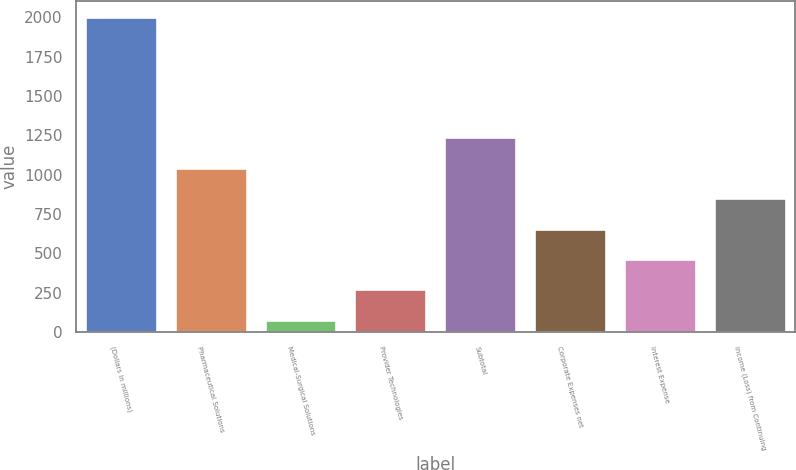Convert chart to OTSL. <chart><loc_0><loc_0><loc_500><loc_500><bar_chart><fcel>(Dollars in millions)<fcel>Pharmaceutical Solutions<fcel>Medical-Surgical Solutions<fcel>Provider Technologies<fcel>Subtotal<fcel>Corporate Expenses net<fcel>Interest Expense<fcel>Income (Loss) from Continuing<nl><fcel>2003<fcel>1043.76<fcel>79.4<fcel>271.76<fcel>1236.12<fcel>656.48<fcel>464.12<fcel>851.4<nl></chart> 